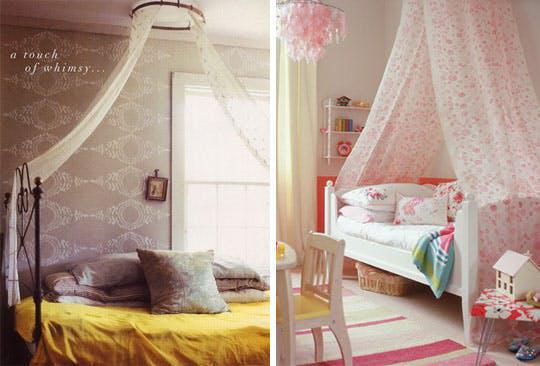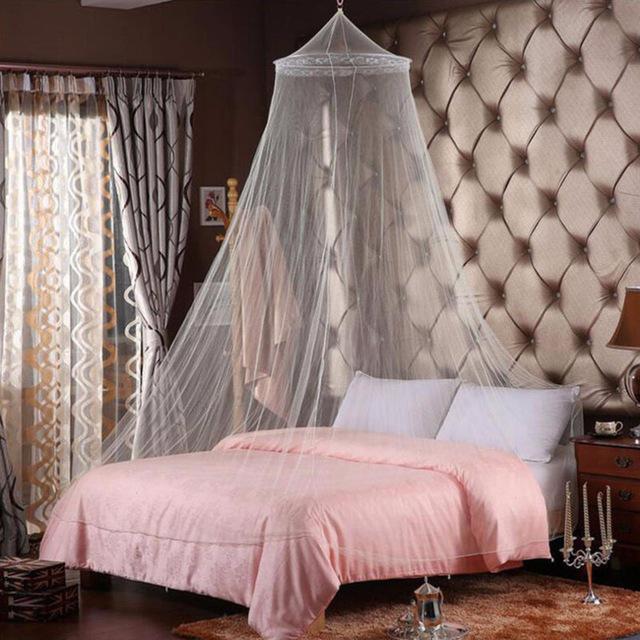The first image is the image on the left, the second image is the image on the right. Considering the images on both sides, is "Each image shows a gauzy canopy that drapes from a round shape suspended from the ceiling, but the left image features a white canopy while the right image features an off-white canopy." valid? Answer yes or no. No. 